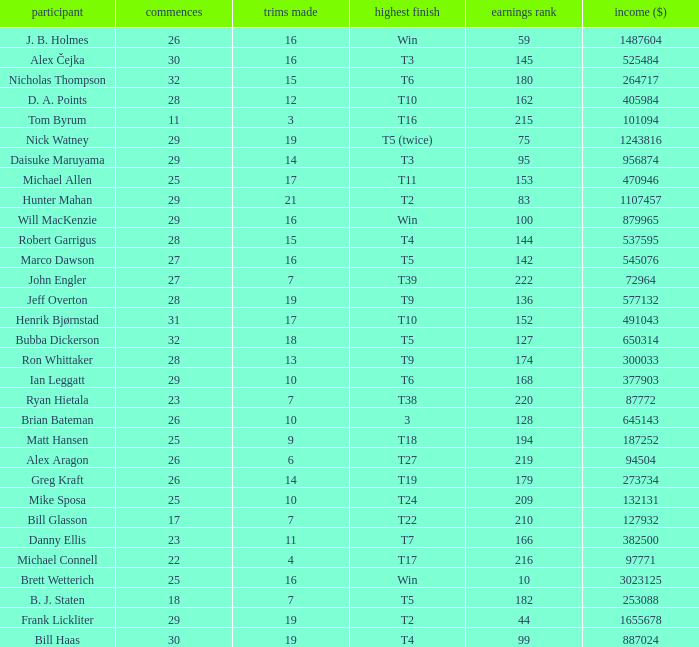What is the maximum money list rank for Matt Hansen? 194.0. 